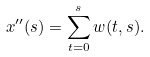<formula> <loc_0><loc_0><loc_500><loc_500>x ^ { \prime \prime } ( s ) = \sum _ { t = 0 } ^ { s } w ( t , s ) .</formula> 